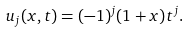Convert formula to latex. <formula><loc_0><loc_0><loc_500><loc_500>u _ { j } ( x , t ) = ( - 1 ) ^ { j } ( 1 + x ) t ^ { j } .</formula> 